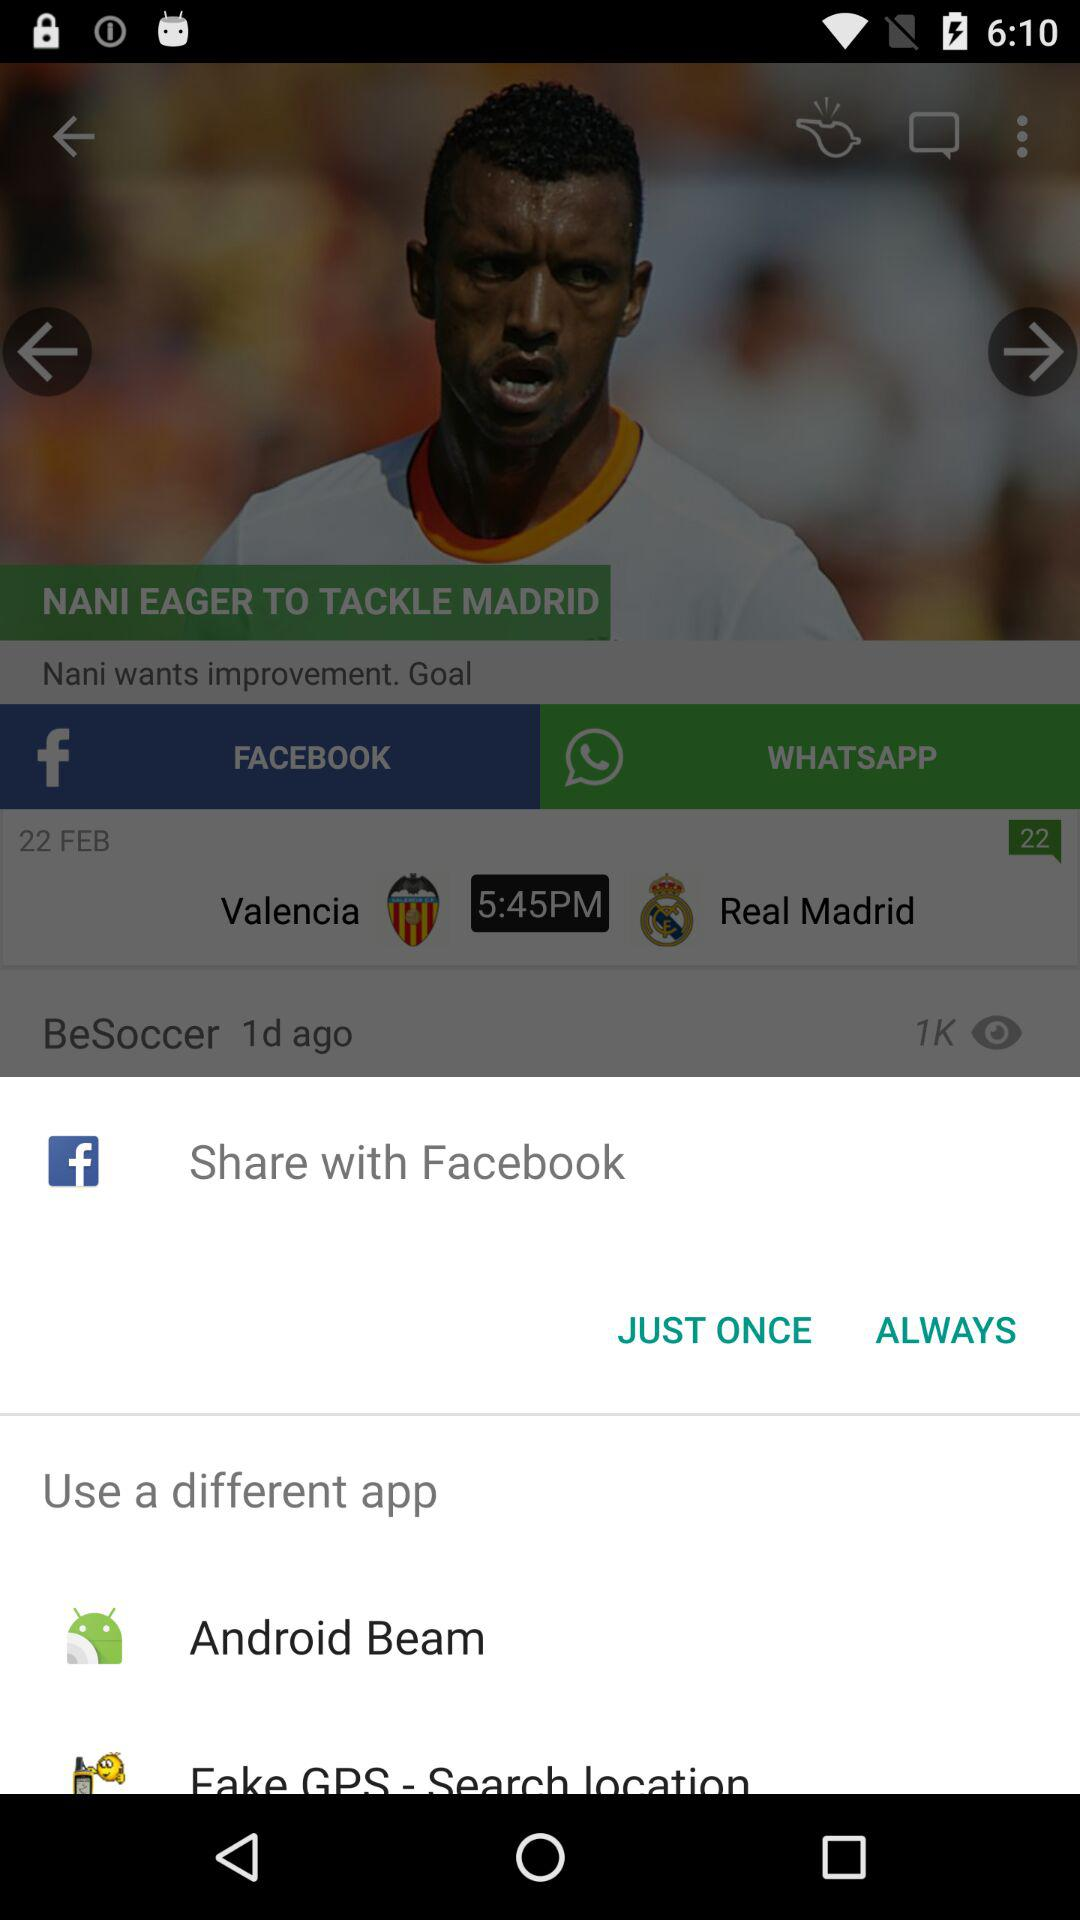Which different sharing options are there? The different sharing options are "Facebook", "Android Beam" and "Fake GPS - Search location". 